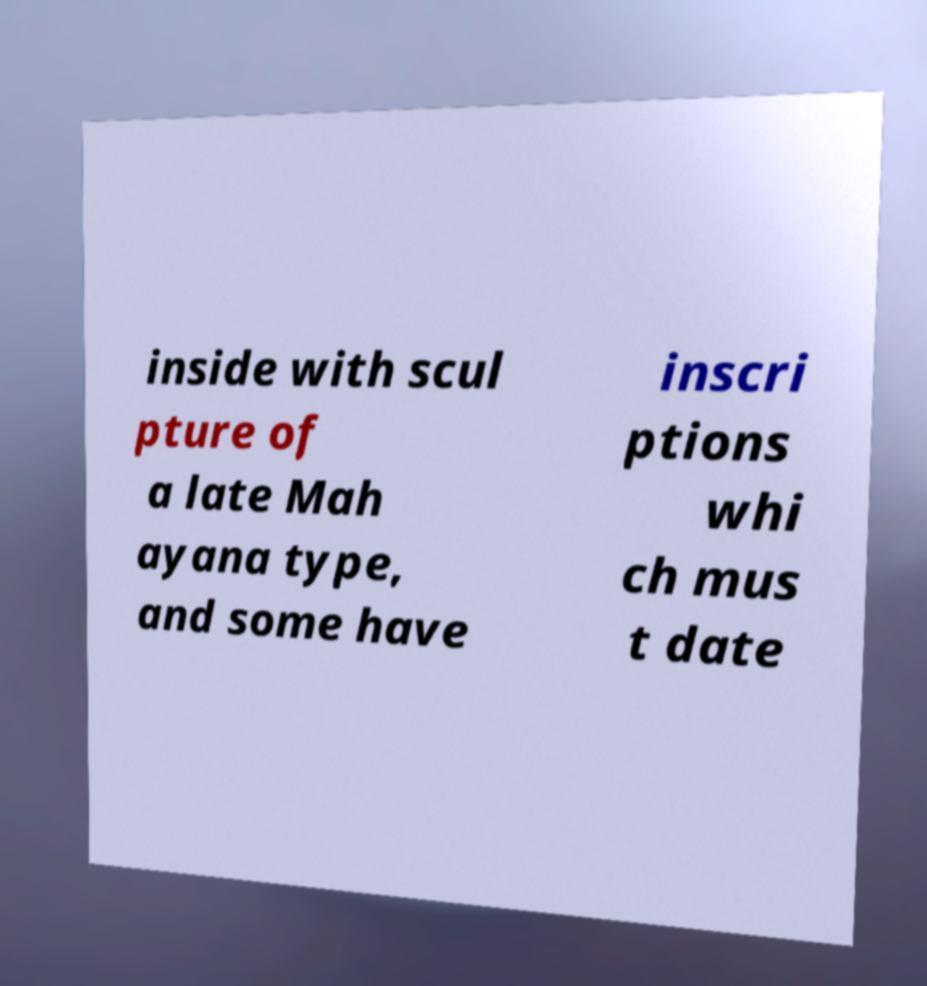Can you read and provide the text displayed in the image?This photo seems to have some interesting text. Can you extract and type it out for me? inside with scul pture of a late Mah ayana type, and some have inscri ptions whi ch mus t date 